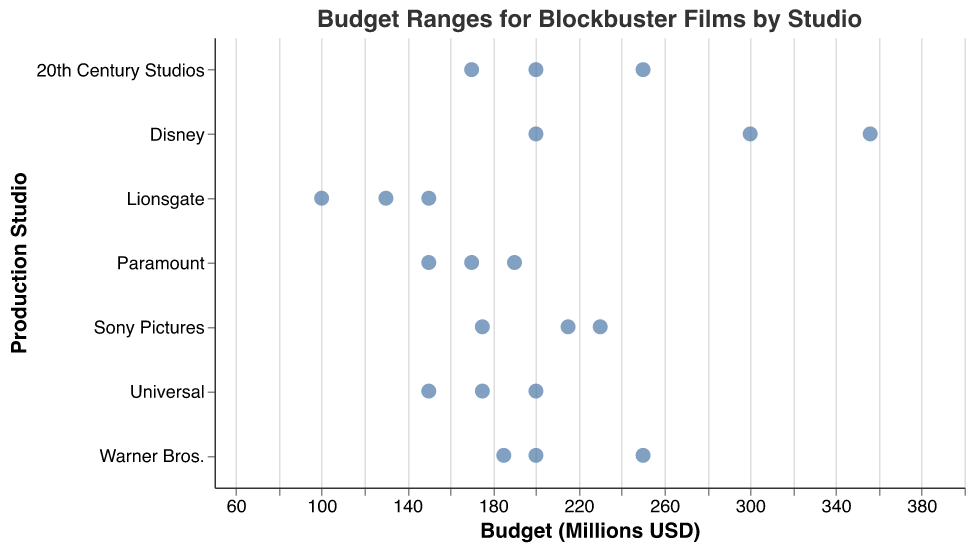What is the highest budget of a Disney film in this dataset? The strip plot shows several "Disney" film budgets, with the highest data point being located at 356 million.
Answer: 356 million How many studios have films with budgets greater than 300 million? By looking at the strip plot, studios with any points positioned beyond the 300 million mark need to be counted. "Warner Bros." and "Disney" are the only ones that pass this threshold.
Answer: 2 What is the budget range for films produced by Universal? The budget range can be determined by identifying the lowest and highest budgets of Universal films. The lowest budget is 150 million, and the highest is 200 million.
Answer: 150-200 million Which studio has the lowest budget film, and what is that budget? The studio with the lowest single data point on the strip plot represents the lowest budget. "Lionsgate" has films with 100 million as the lowest budget.
Answer: Lionsgate, 100 million Calculate the average budget for films made by Warner Bros. To get the average, add the budgets of Warner Bros. (185, 200, 250) and divide by the number of entries. So, (185 + 200 + 250) / 3 = 635 / 3.
Answer: ~211.67 million Which studio shows the greatest variability in film budgets? Variability can be assessed by the spread between the minimum and maximum budget data points for each studio. Disney shows the greatest spread, from 200 to 356 million, a range of 156 million.
Answer: Disney Compare the budget ranges for Sony Pictures and Lionsgate. Which has a higher range? The range for Sony Pictures is from 175 to 230 million, while Lionsgate ranges from 100 to 150 million. Sony Pictures' range is 55 million and Lionsgate's range is 50 million.
Answer: Sony Pictures What is the median budget for films produced by 20th Century Studios? Arrange the budgets of 20th Century Studios (170, 200, 250) in ascending order and identify the middle value. The middle number among 170, 200, and 250 is 200.
Answer: 200 million Which studio has the most consistently budgeted films? Consistency refers to low variability within each studio's budgets. Universal's films range narrowly between 150 and 200 million.
Answer: Universal Are there any studios with films having the same budget in this dataset? Check for any studios with repeated data points. No repeated budget values for any studio are seen in the plot. Each budget value is unique per studio.
Answer: No 